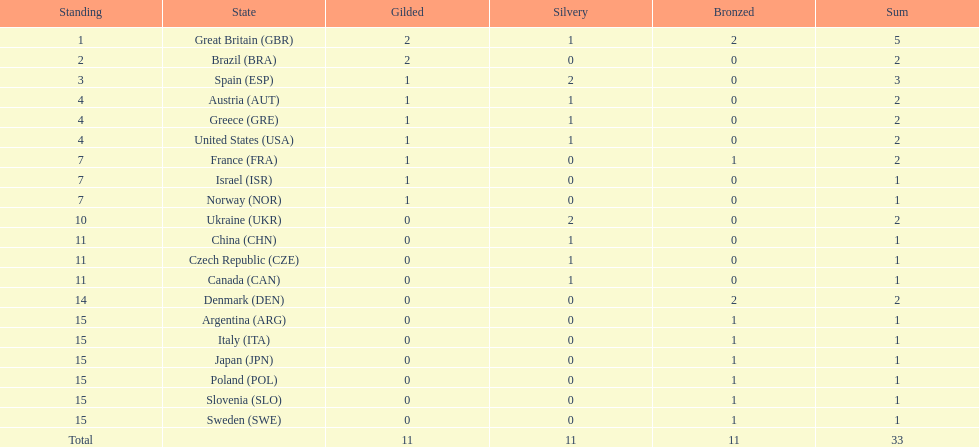What nation was next to great britain in total medal count? Spain. 